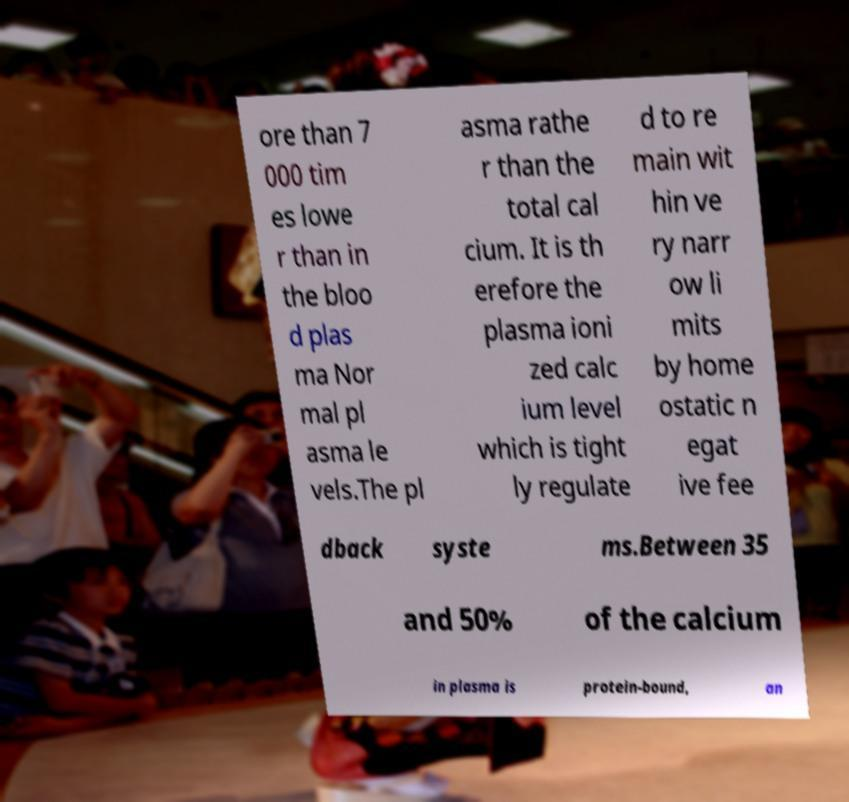Please identify and transcribe the text found in this image. ore than 7 000 tim es lowe r than in the bloo d plas ma Nor mal pl asma le vels.The pl asma rathe r than the total cal cium. It is th erefore the plasma ioni zed calc ium level which is tight ly regulate d to re main wit hin ve ry narr ow li mits by home ostatic n egat ive fee dback syste ms.Between 35 and 50% of the calcium in plasma is protein-bound, an 